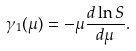<formula> <loc_0><loc_0><loc_500><loc_500>\gamma _ { 1 } ( \mu ) = - \mu \frac { d \ln S } { d \mu } .</formula> 